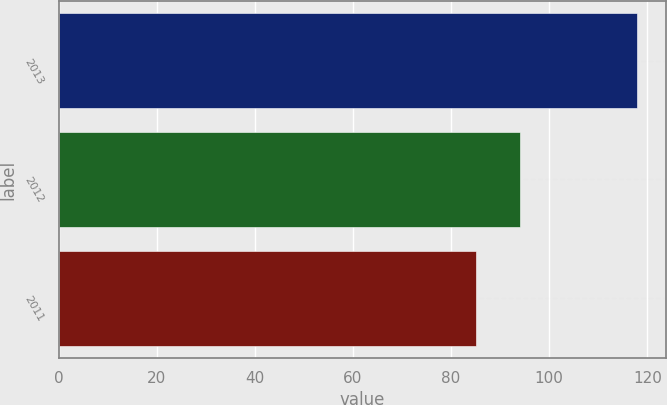Convert chart. <chart><loc_0><loc_0><loc_500><loc_500><bar_chart><fcel>2013<fcel>2012<fcel>2011<nl><fcel>118<fcel>94<fcel>85<nl></chart> 